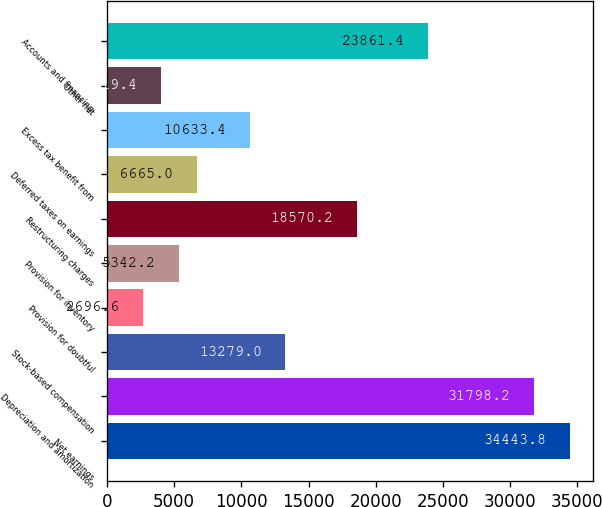Convert chart to OTSL. <chart><loc_0><loc_0><loc_500><loc_500><bar_chart><fcel>Net earnings<fcel>Depreciation and amortization<fcel>Stock-based compensation<fcel>Provision for doubtful<fcel>Provision for inventory<fcel>Restructuring charges<fcel>Deferred taxes on earnings<fcel>Excess tax benefit from<fcel>Other net<fcel>Accounts and financing<nl><fcel>34443.8<fcel>31798.2<fcel>13279<fcel>2696.6<fcel>5342.2<fcel>18570.2<fcel>6665<fcel>10633.4<fcel>4019.4<fcel>23861.4<nl></chart> 